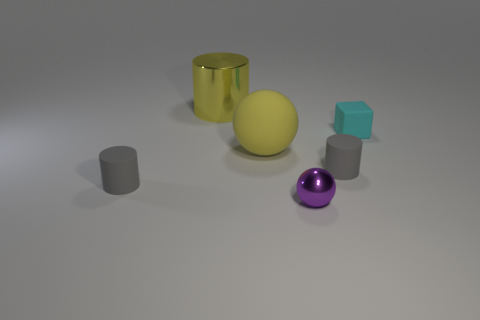Subtract all small cylinders. How many cylinders are left? 1 Add 1 big yellow metal cylinders. How many objects exist? 7 Subtract all blue cylinders. Subtract all purple spheres. How many cylinders are left? 3 Subtract all balls. How many objects are left? 4 Subtract all small cyan matte objects. Subtract all big shiny cylinders. How many objects are left? 4 Add 6 tiny cyan objects. How many tiny cyan objects are left? 7 Add 6 big metal things. How many big metal things exist? 7 Subtract 1 yellow cylinders. How many objects are left? 5 